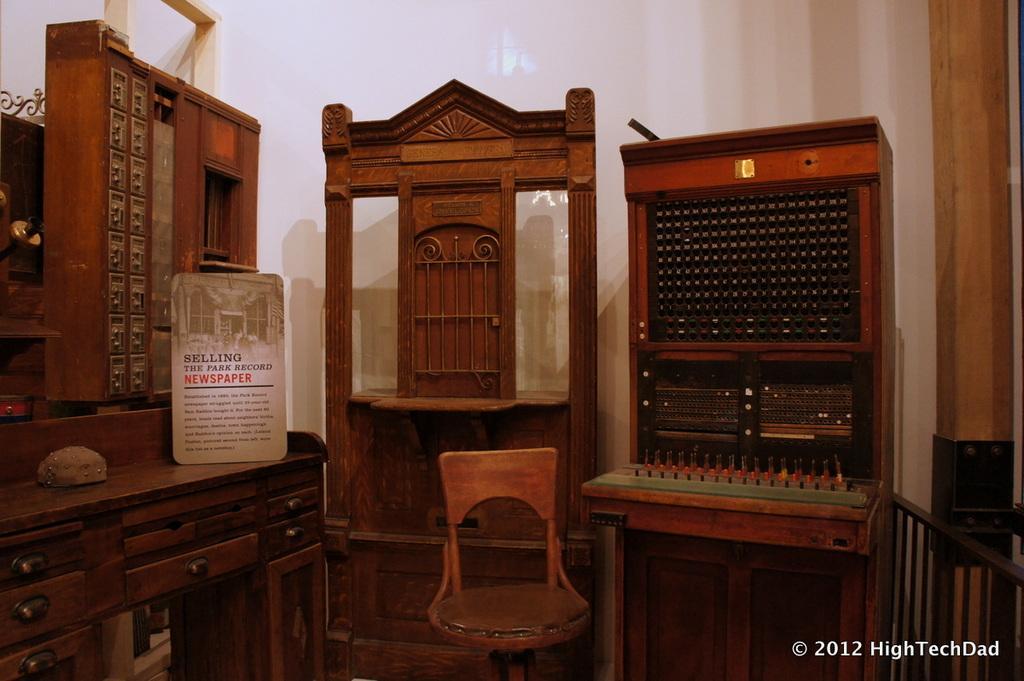Could you give a brief overview of what you see in this image? Here in the center we can see a chair and at the back side we can see some kind of furniture items 